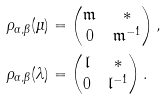<formula> <loc_0><loc_0><loc_500><loc_500>\rho _ { \alpha , \beta } ( \mu ) & = \begin{pmatrix} \mathfrak { m } & \ast \\ 0 & \mathfrak { m } ^ { - 1 } \end{pmatrix} , \\ \rho _ { \alpha , \beta } ( \lambda ) & = \begin{pmatrix} \mathfrak { l } & \ast \\ 0 & \mathfrak { l } ^ { - 1 } \end{pmatrix} .</formula> 